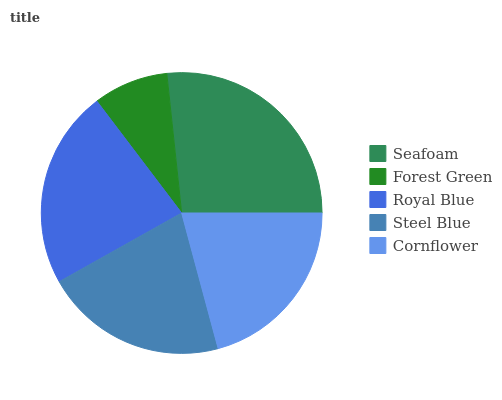Is Forest Green the minimum?
Answer yes or no. Yes. Is Seafoam the maximum?
Answer yes or no. Yes. Is Royal Blue the minimum?
Answer yes or no. No. Is Royal Blue the maximum?
Answer yes or no. No. Is Royal Blue greater than Forest Green?
Answer yes or no. Yes. Is Forest Green less than Royal Blue?
Answer yes or no. Yes. Is Forest Green greater than Royal Blue?
Answer yes or no. No. Is Royal Blue less than Forest Green?
Answer yes or no. No. Is Steel Blue the high median?
Answer yes or no. Yes. Is Steel Blue the low median?
Answer yes or no. Yes. Is Seafoam the high median?
Answer yes or no. No. Is Forest Green the low median?
Answer yes or no. No. 